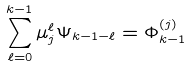<formula> <loc_0><loc_0><loc_500><loc_500>\sum _ { \ell = 0 } ^ { k - 1 } \mu _ { j } ^ { \ell } \Psi _ { k - 1 - \ell } = \Phi _ { k - 1 } ^ { ( j ) }</formula> 